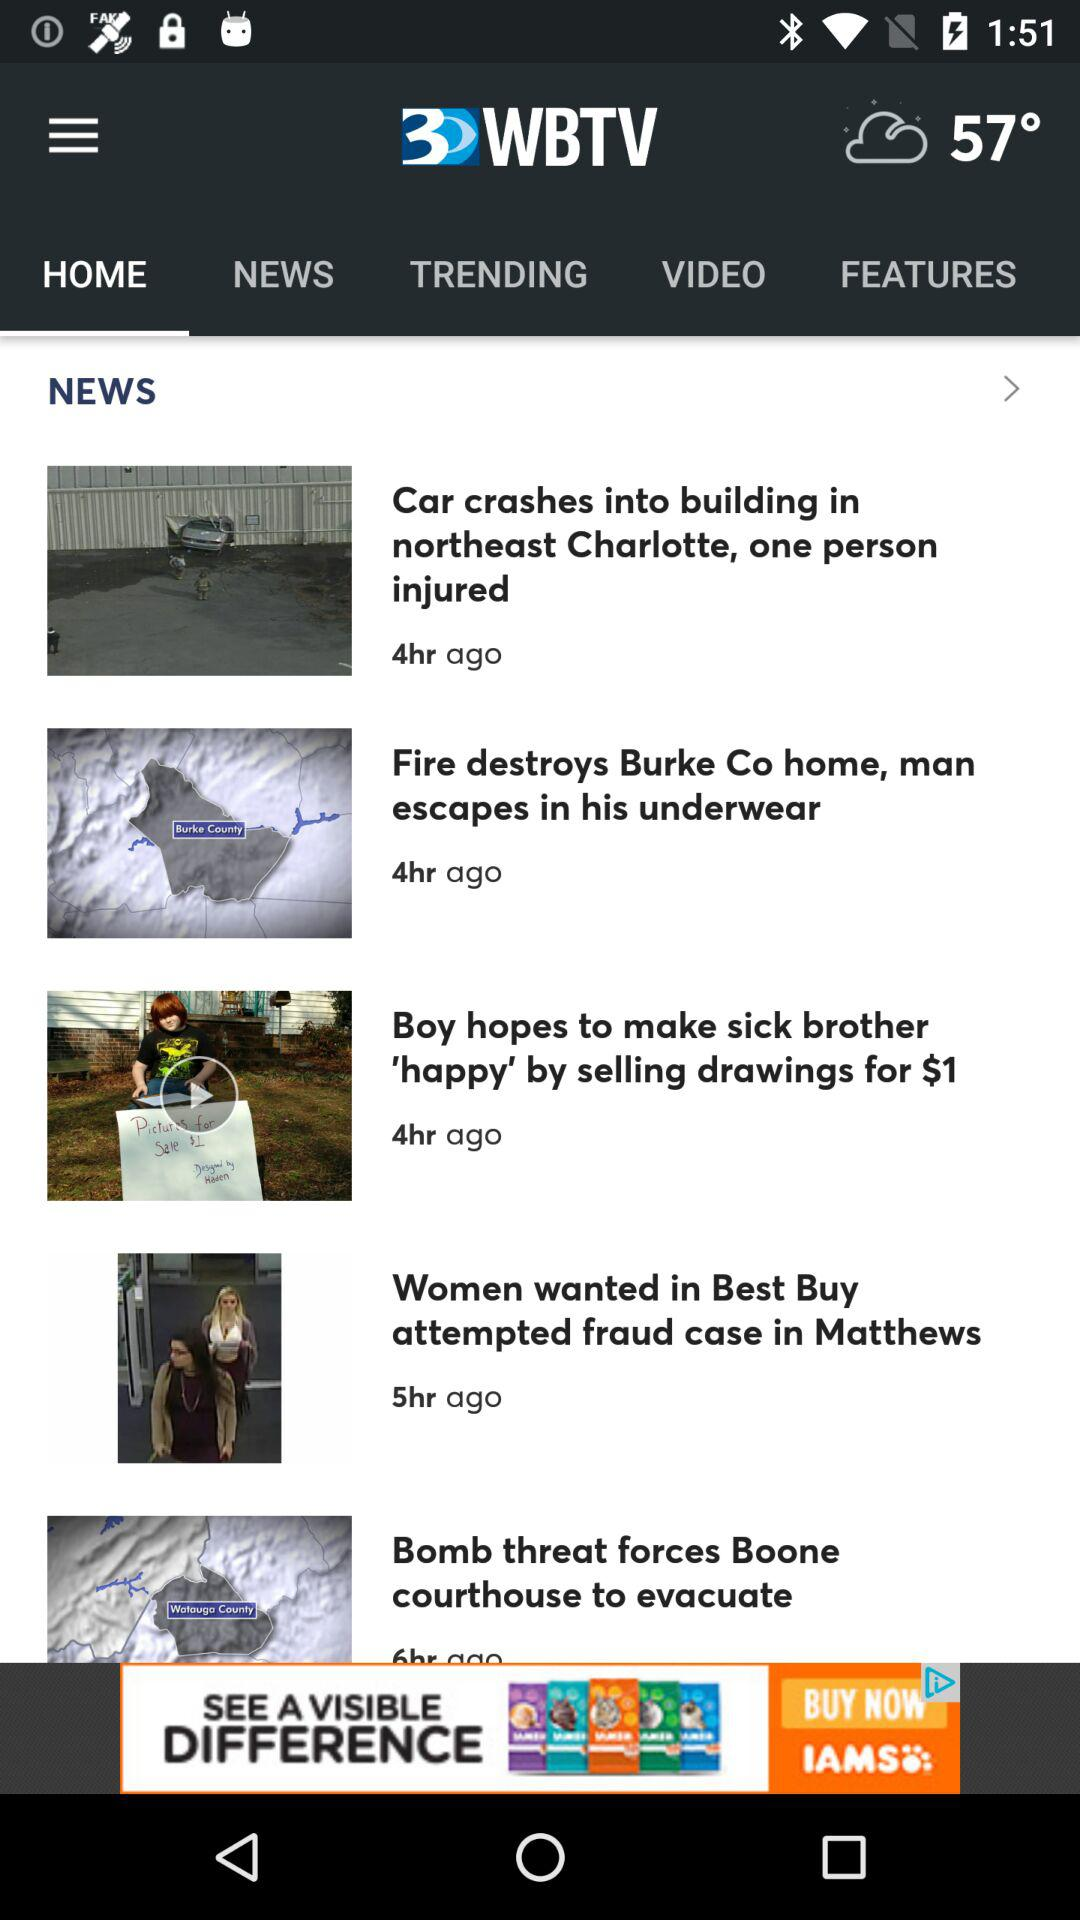How is the weather? The weather is cloudy. 